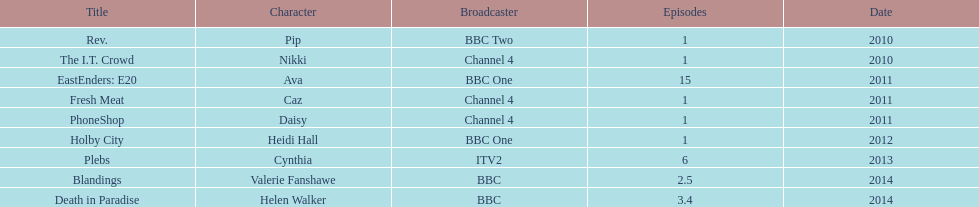What is the unique role she performed with broadcaster itv2? Cynthia. 